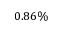Convert formula to latex. <formula><loc_0><loc_0><loc_500><loc_500>0 . 8 6 \%</formula> 